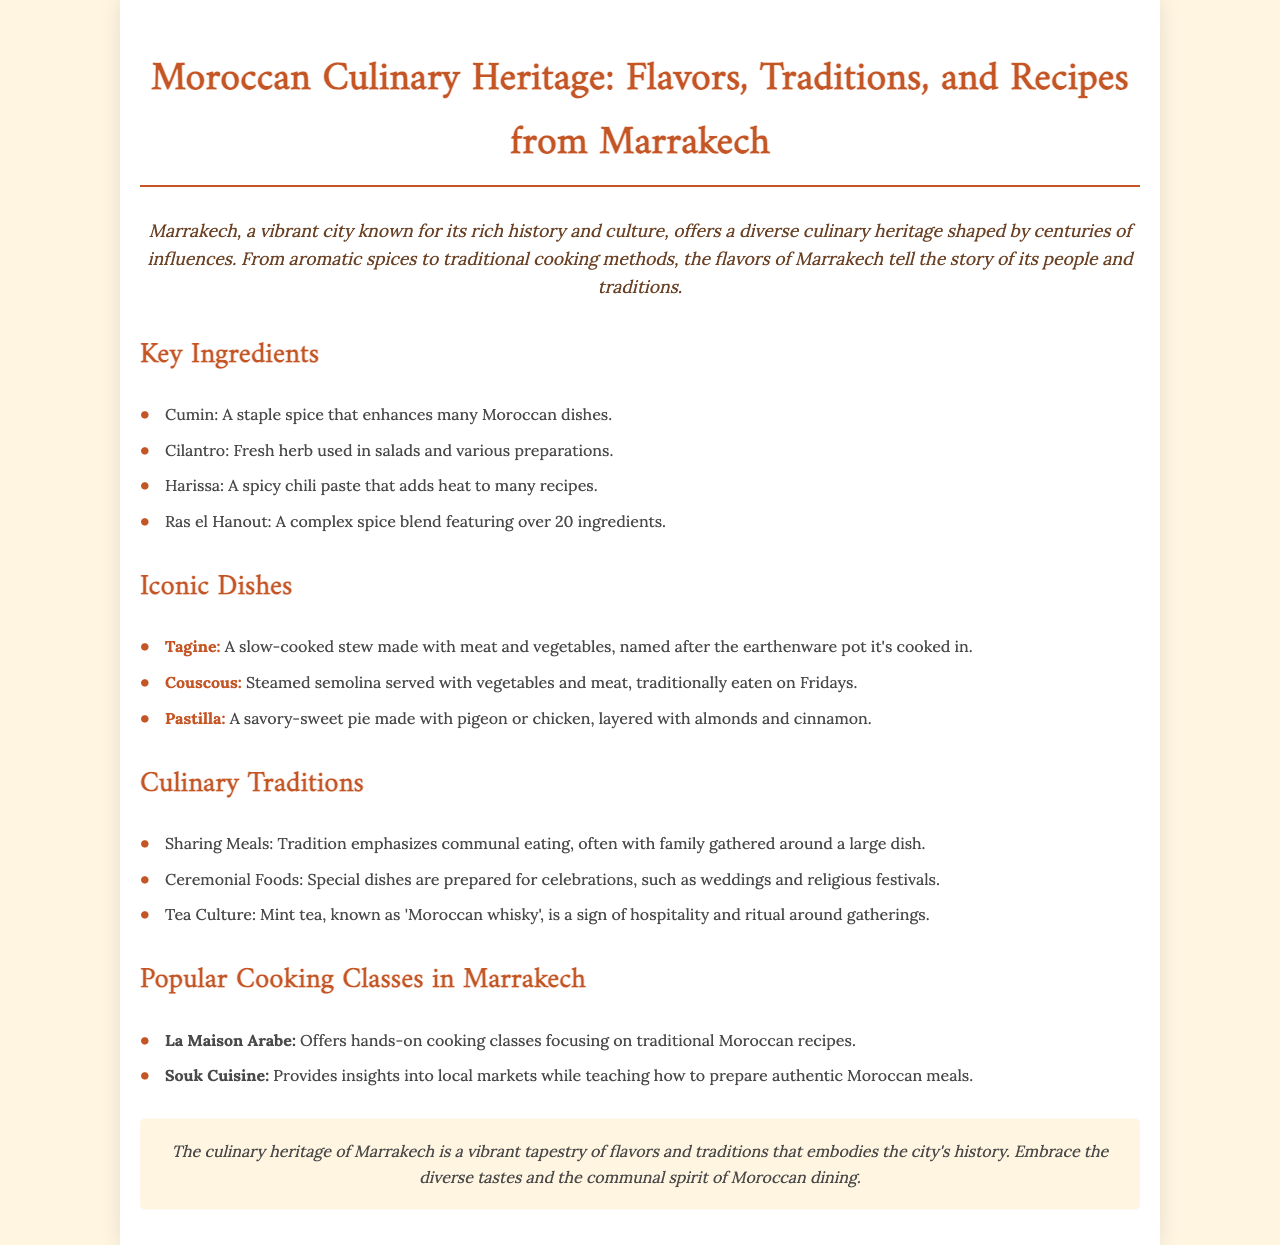What is the introduction about? The introduction discusses Marrakech's vibrant history and culture, highlighting its diverse culinary heritage shaped by influences over the centuries.
Answer: Marrakech's vibrant history and culture What is a staple spice mentioned in the document? Cumin is mentioned as a staple spice that enhances many Moroccan dishes.
Answer: Cumin What traditional dish is served on Fridays? The document states that Couscous is traditionally eaten on Fridays.
Answer: Couscous What cooking class focuses on traditional Moroccan recipes? La Maison Arabe is specified as offering hands-on cooking classes focusing on traditional Moroccan recipes.
Answer: La Maison Arabe What is known as 'Moroccan whisky'? The document refers to mint tea as 'Moroccan whisky', indicating its significance in hospitality.
Answer: Mint tea What kind of cuisine does Souk Cuisine provide? Souk Cuisine provides insights into local markets while teaching how to prepare authentic Moroccan meals.
Answer: Authentic Moroccan meals How many iconic dishes are listed in the document? Three iconic dishes are mentioned in the document: Tagine, Couscous, and Pastilla.
Answer: Three What are ceremonial foods used for? Special dishes are prepared for celebrations, such as weddings and religious festivals.
Answer: Celebrations What does the conclusion emphasize about Marrakech's culinary heritage? The conclusion emphasizes that the culinary heritage of Marrakech is a vibrant tapestry of flavors and traditions embodying the city's history.
Answer: A vibrant tapestry of flavors and traditions 